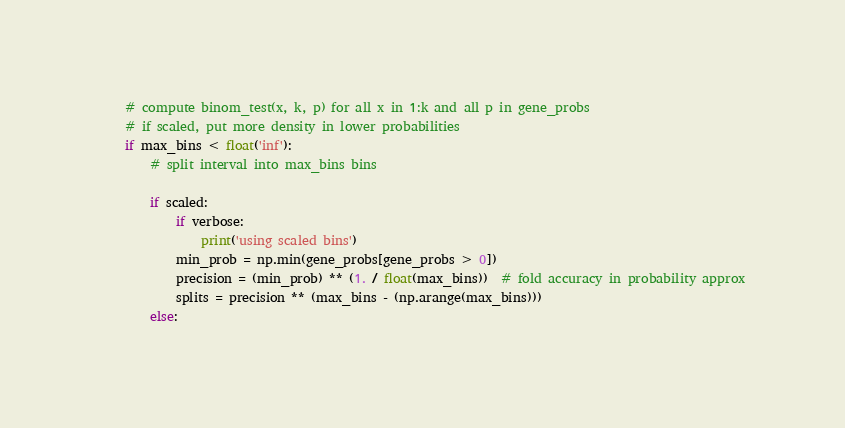Convert code to text. <code><loc_0><loc_0><loc_500><loc_500><_Python_>    # compute binom_test(x, k, p) for all x in 1:k and all p in gene_probs
    # if scaled, put more density in lower probabilities
    if max_bins < float('inf'):
        # split interval into max_bins bins

        if scaled:
            if verbose:
                print('using scaled bins')
            min_prob = np.min(gene_probs[gene_probs > 0])
            precision = (min_prob) ** (1. / float(max_bins))  # fold accuracy in probability approx
            splits = precision ** (max_bins - (np.arange(max_bins)))
        else:</code> 